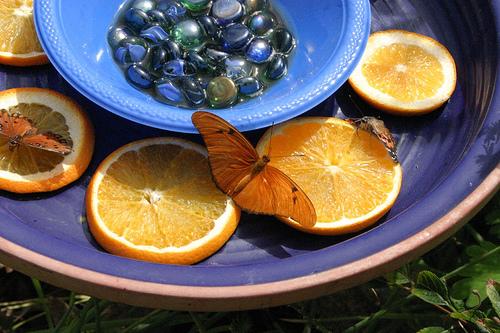How many butterflies are in this scene?
Give a very brief answer. 3. Does the insect have the same color as the fruit?
Give a very brief answer. Yes. What's in the bowl?
Answer briefly. Marbles. 